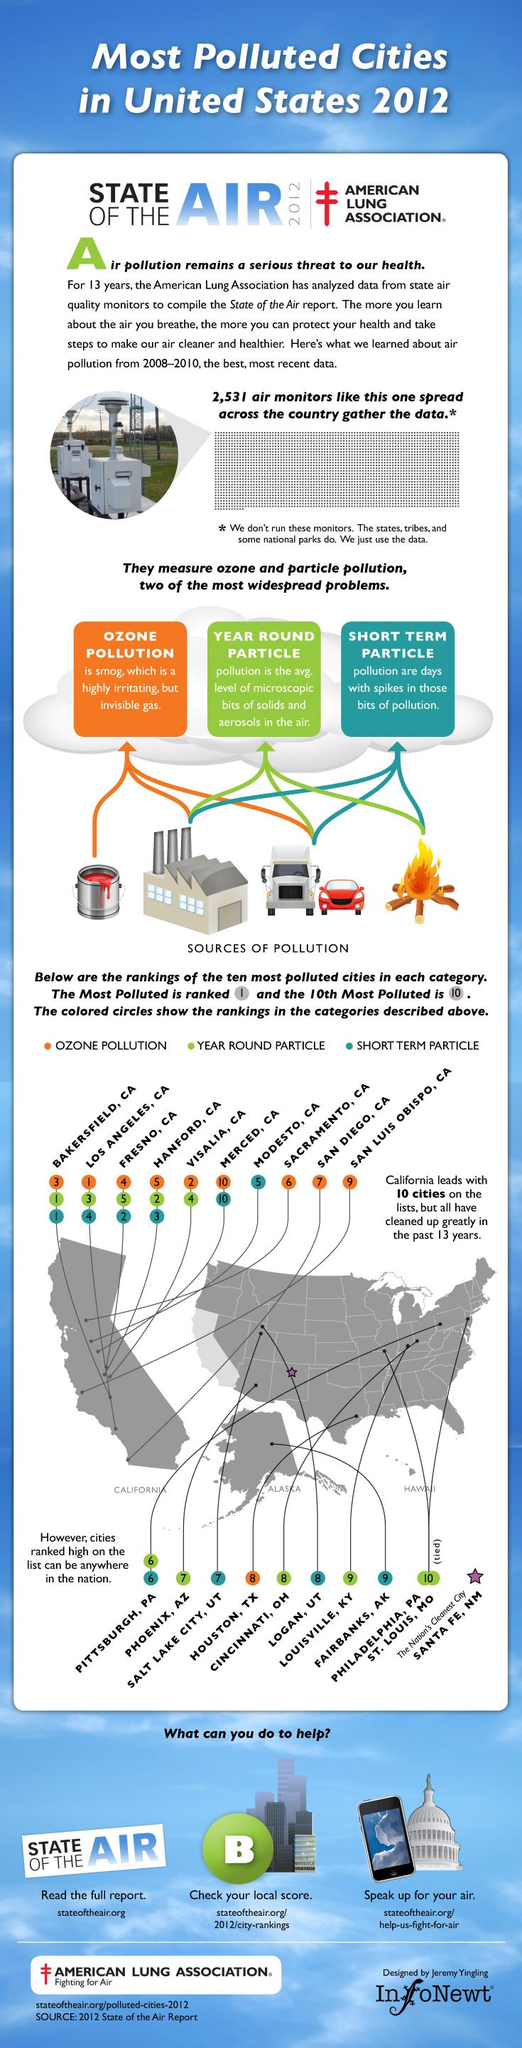Outline some significant characteristics in this image. Smog is the highly irritating and invisible gas that is mentioned. 